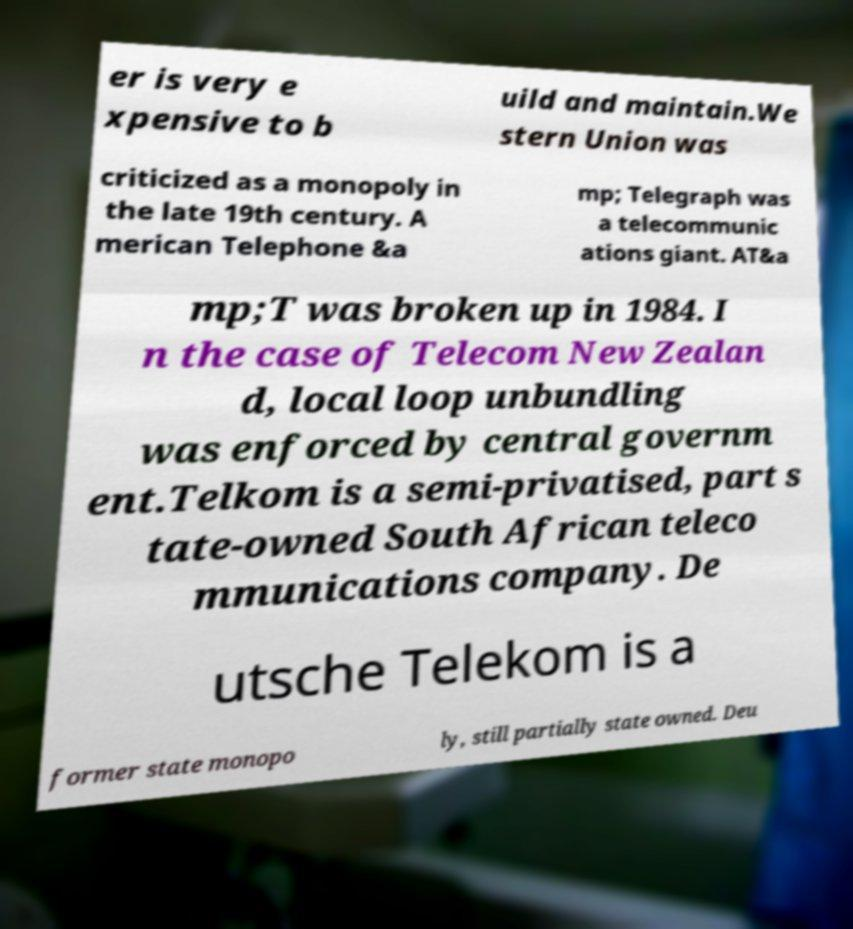What messages or text are displayed in this image? I need them in a readable, typed format. er is very e xpensive to b uild and maintain.We stern Union was criticized as a monopoly in the late 19th century. A merican Telephone &a mp; Telegraph was a telecommunic ations giant. AT&a mp;T was broken up in 1984. I n the case of Telecom New Zealan d, local loop unbundling was enforced by central governm ent.Telkom is a semi-privatised, part s tate-owned South African teleco mmunications company. De utsche Telekom is a former state monopo ly, still partially state owned. Deu 